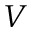<formula> <loc_0><loc_0><loc_500><loc_500>V</formula> 